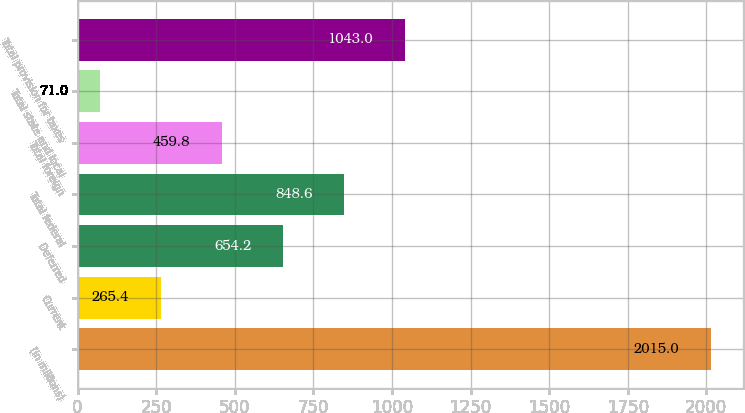<chart> <loc_0><loc_0><loc_500><loc_500><bar_chart><fcel>(in millions)<fcel>Current<fcel>Deferred<fcel>Total federal<fcel>Total foreign<fcel>Total state and local<fcel>Total provision for taxes<nl><fcel>2015<fcel>265.4<fcel>654.2<fcel>848.6<fcel>459.8<fcel>71<fcel>1043<nl></chart> 